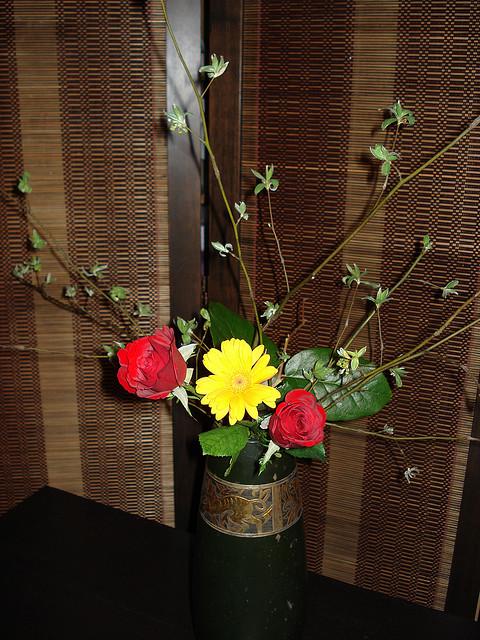What kind of material is in the background?
Keep it brief. Bamboo. How many roses are in the vase?
Quick response, please. 2. Are there any purple flowers here?
Concise answer only. No. 